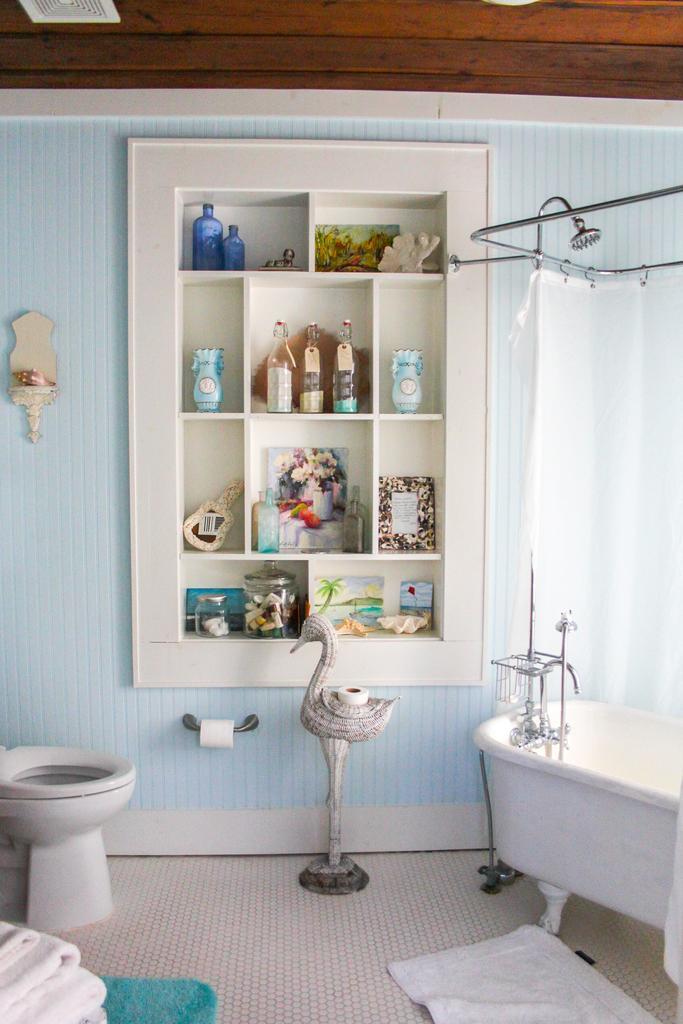Describe this image in one or two sentences. In the picture we can see inside the washroom with a toilet seat which is white in color and inside we can see a tissue roll to the wall and bath tub which is white in color and to the wall we can see some racks with some things like liquid bottles, photo frames and to the floor we can see some floor mat which is white in color. 